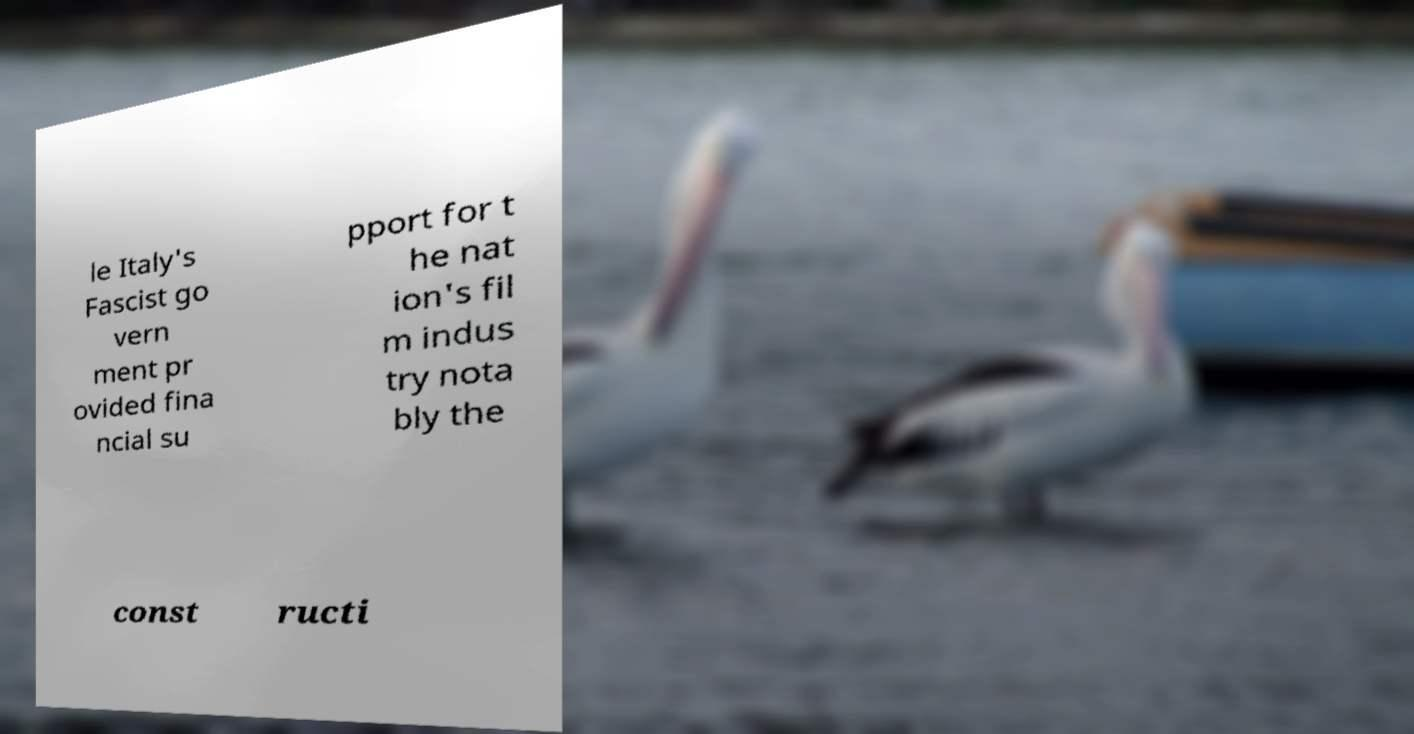For documentation purposes, I need the text within this image transcribed. Could you provide that? le Italy's Fascist go vern ment pr ovided fina ncial su pport for t he nat ion's fil m indus try nota bly the const ructi 